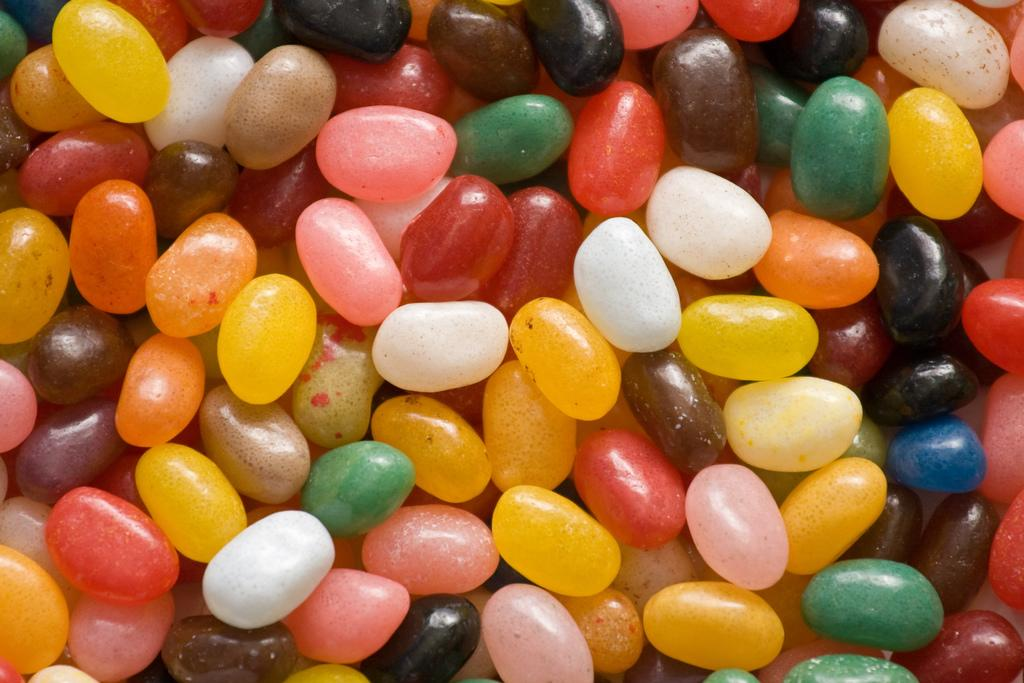What type of objects are present in the image? There are chocolate gems of different colors in the image. Can you describe the appearance of the chocolate gems? The chocolate gems are of different colors. How many different colors can be seen among the chocolate gems? The number of different colors among the chocolate gems is not specified in the facts provided. What is the monkey's opinion on the chocolate gems in the image? There is no monkey present in the image, so it is not possible to determine its opinion on the chocolate gems. 